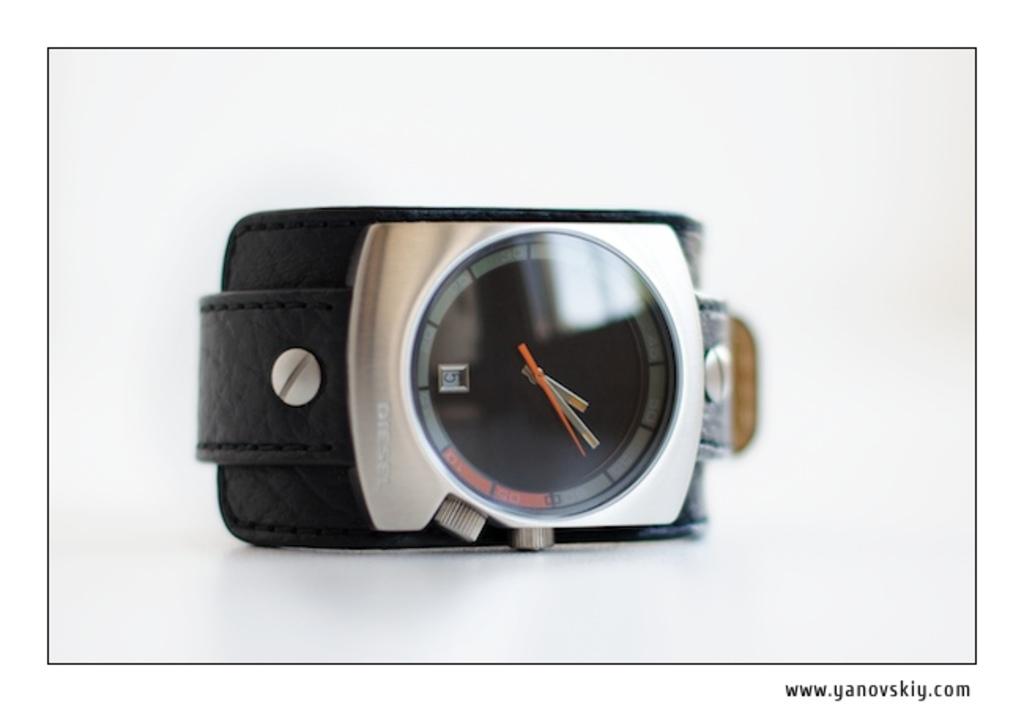What website is written on this image?
Your answer should be very brief. Www.yanovskiy.com. 